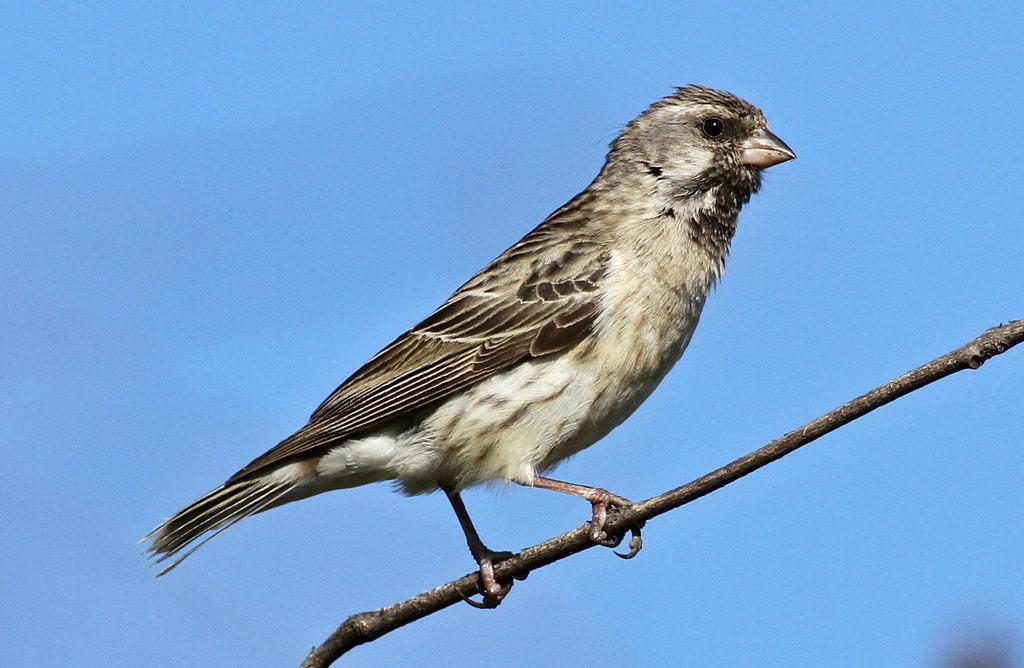How would you summarize this image in a sentence or two? In this picture we can see a bird is standing on the branch. Behind the bird there is the sky. 